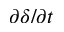Convert formula to latex. <formula><loc_0><loc_0><loc_500><loc_500>\partial \delta / \partial t</formula> 